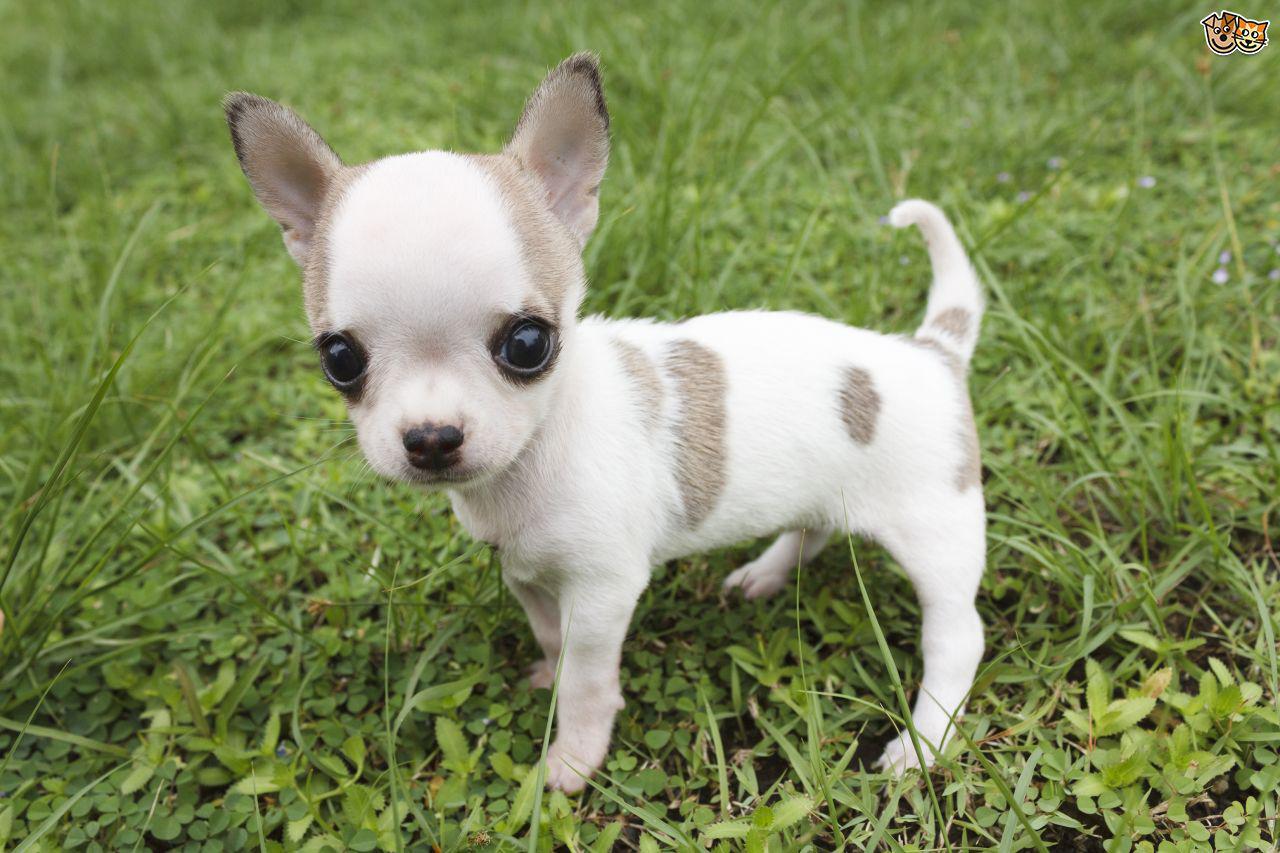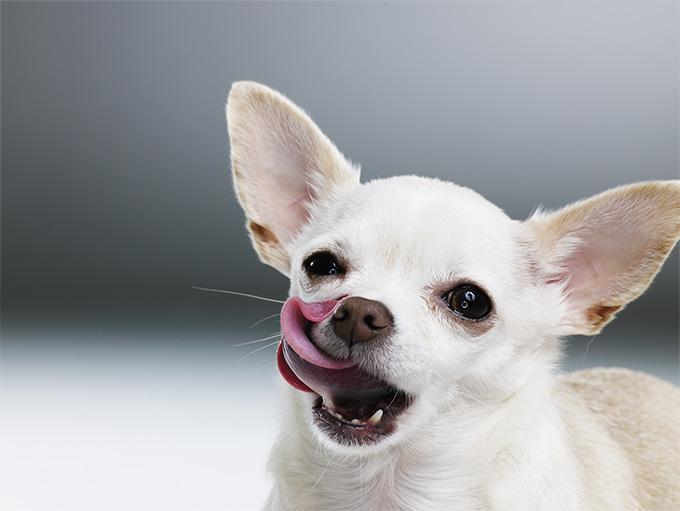The first image is the image on the left, the second image is the image on the right. Assess this claim about the two images: "there are two dogs whose full body is shown on the image". Correct or not? Answer yes or no. No. 